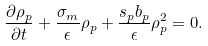Convert formula to latex. <formula><loc_0><loc_0><loc_500><loc_500>\frac { \partial \rho _ { p } } { \partial t } + \frac { \sigma _ { m } } { \epsilon } \rho _ { p } + \frac { s _ { p } b _ { p } } { \epsilon } \rho _ { p } ^ { 2 } = 0 .</formula> 